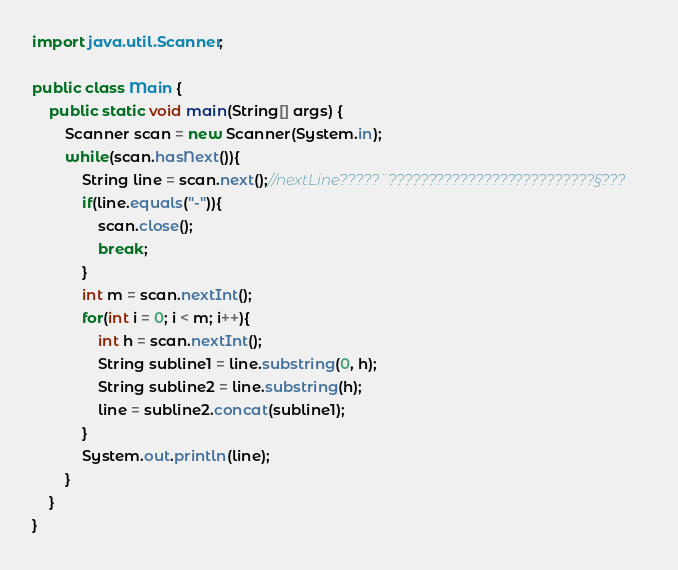<code> <loc_0><loc_0><loc_500><loc_500><_Java_>import java.util.Scanner;

public class Main {
	public static void main(String[] args) {
		Scanner scan = new Scanner(System.in);
		while(scan.hasNext()){
			String line = scan.next();//nextLine?????¨??????????????????????????§???
			if(line.equals("-")){
				scan.close();
				break;
			}
			int m = scan.nextInt();
			for(int i = 0; i < m; i++){
				int h = scan.nextInt();
				String subline1 = line.substring(0, h);
				String subline2 = line.substring(h);
				line = subline2.concat(subline1);
			}
			System.out.println(line);
		}
	}
}</code> 